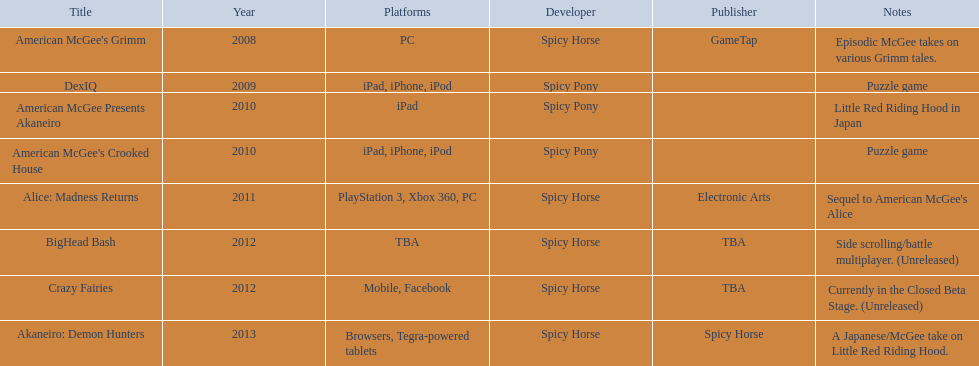What are the showcased spicy horse titles? American McGee's Grimm, DexIQ, American McGee Presents Akaneiro, American McGee's Crooked House, Alice: Madness Returns, BigHead Bash, Crazy Fairies, Akaneiro: Demon Hunters. Which ones are designed for the ipad? DexIQ, American McGee Presents Akaneiro, American McGee's Crooked House. Out of those, which ones don't work on the iphone or ipod? American McGee Presents Akaneiro. 